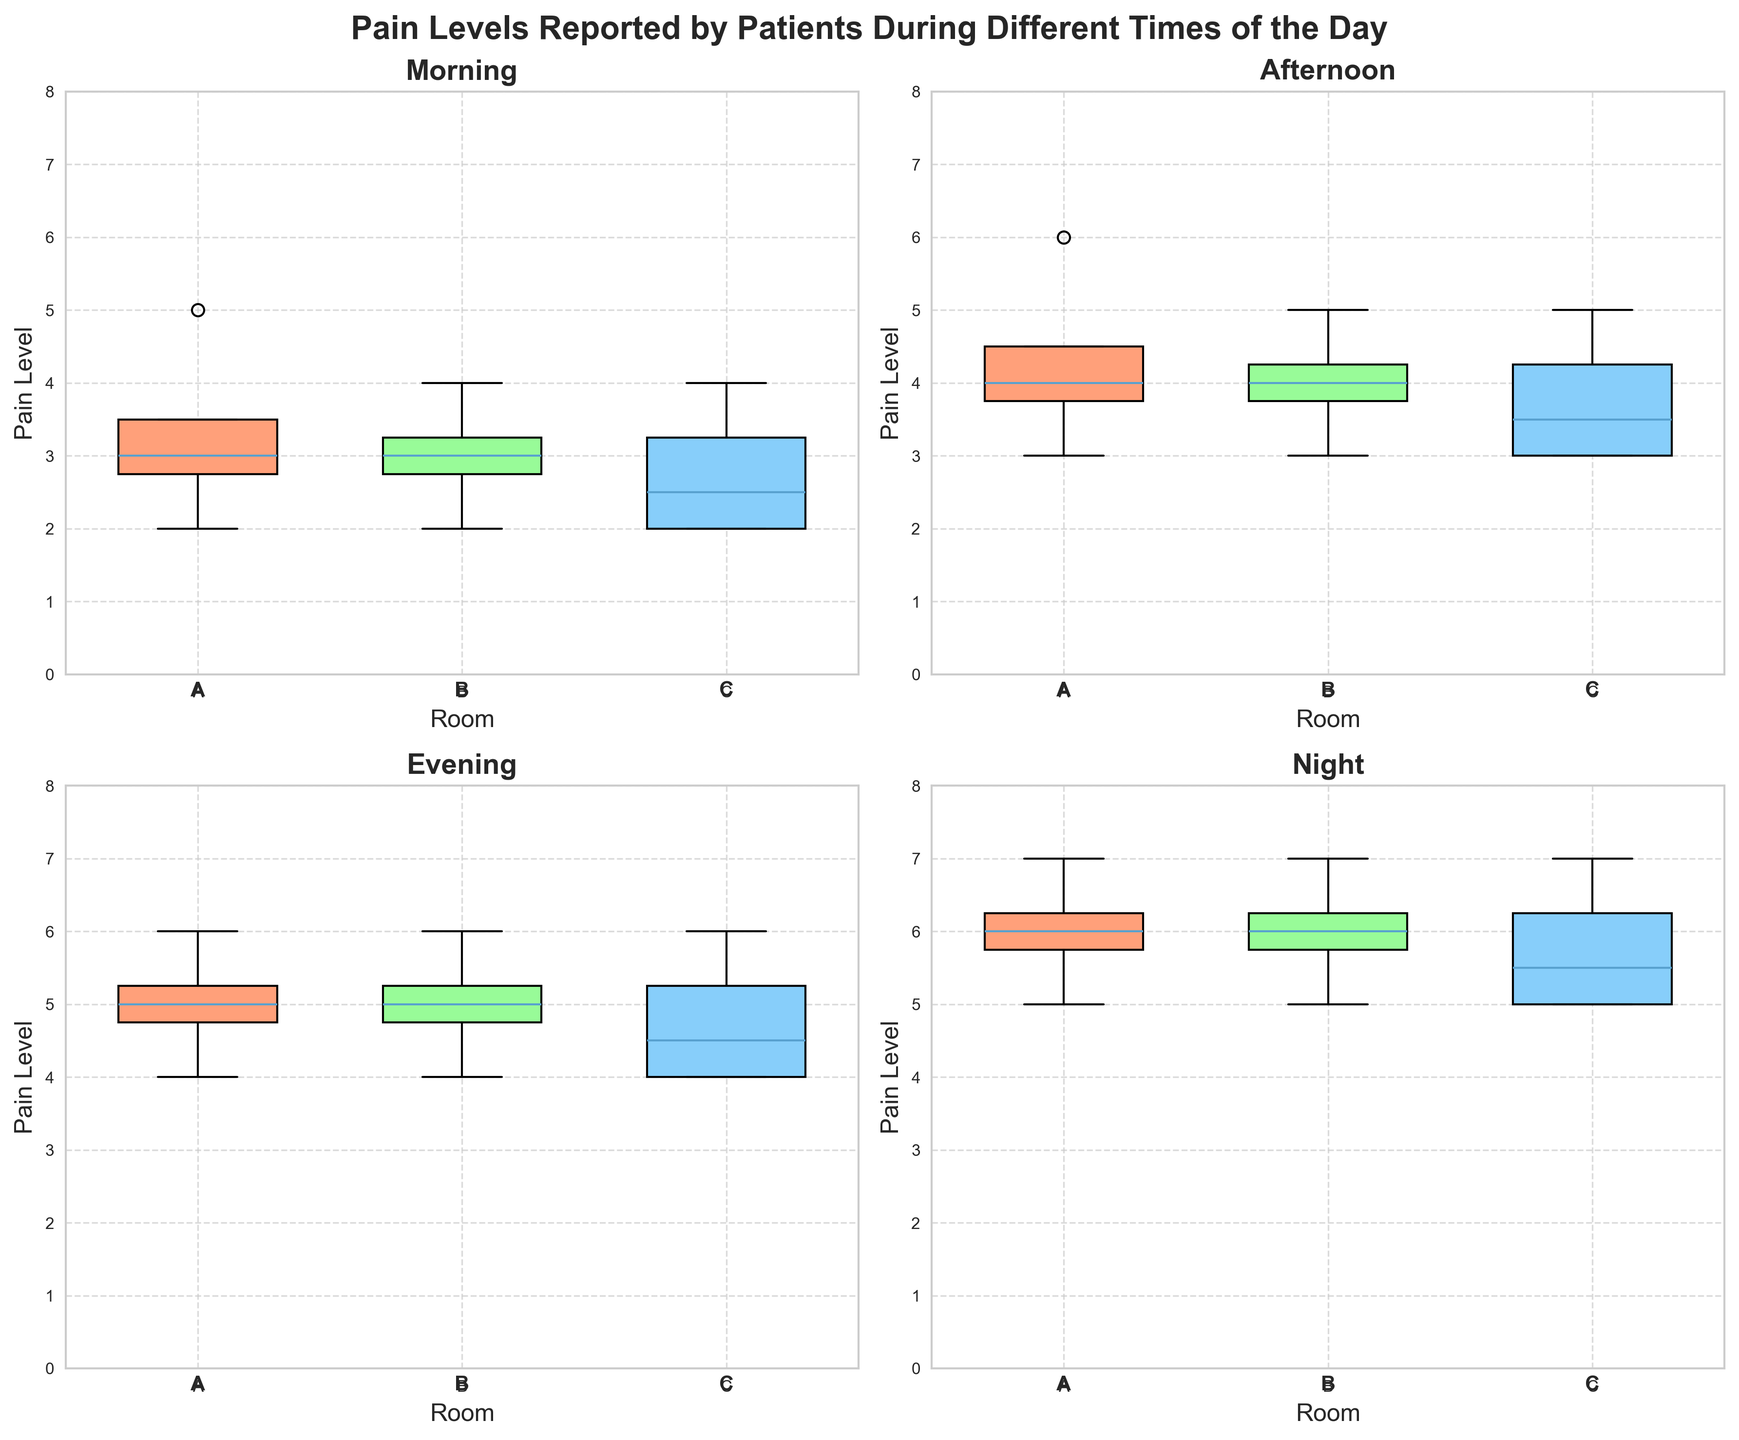What is the title of the figure? The title is located at the top of the figure. It is 'Pain Levels Reported by Patients During Different Times of the Day'.
Answer: Pain Levels Reported by Patients During Different Times of the Day What are the colors used for the different times of the day in the box plots? Each time of the day is associated with a specific color. Morning is represented by Salmon, Afternoon by Light Green, Evening by Light Blue, and Night by Light Purple.
Answer: Salmon, Light Green, Light Blue, Light Purple Which room has the highest median pain level during the night? For the Night subplot, look at the median line (central line inside the box) of each box plot. Room B has the highest median pain level.
Answer: Room B What is the range of pain levels reported in Room B during the afternoon? In the Afternoon subplot, examine the box plot for Room B. The minimum value (lower whisker) is 3 and the maximum value (upper whisker) is 5.
Answer: 3 to 5 How do the median pain levels compare between Room A and Room C during the evening? In the Evening subplot, compare the median lines inside the box plots of Room A and Room C. Both rooms have the same median pain level, indicated by the central line.
Answer: Equal Which time of day shows the lowest variability in pain levels for Room C? Variability is shown by the length of the box and whiskers. In the box plots for Room C, the Morning subplot shows the shortest combined box and whisker length, indicating the lowest variability.
Answer: Morning What is the interquartile range (IQR) of pain levels in Room A during the morning? The IQR is the difference between the upper quartile (top edge of the box) and the lower quartile (bottom edge of the box). For Room A in the Morning subplot, the upper quartile is 3.5 and the lower quartile is 2. The IQR is 3.5 - 2.
Answer: 1.5 Which room has the smallest upper quartile pain level during the afternoon? For the Afternoon subplot, compare the upper edges of the boxes. Room B has the lowest upper quartile, indicated by the top edge of the box.
Answer: Room B During which time of day do patients in Room A report the highest range of pain levels? The range is the difference between the whiskers. For Room A, the difference is highest during the Night time as the whiskers are most spread out.
Answer: Night What is the median pain level in Room C during the morning? In the Morning subplot, look at the central line inside the box plot of Room C. The median pain level is 2.5.
Answer: 2.5 